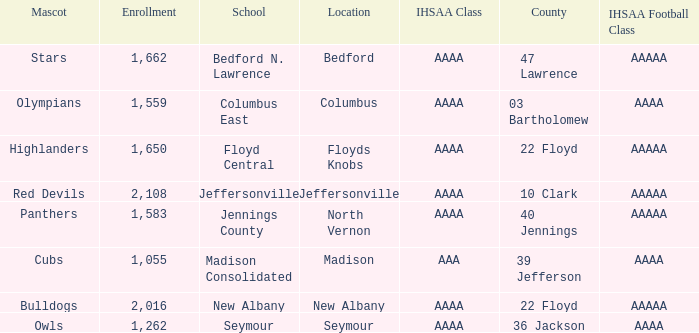What is bedford's mascot? Stars. 